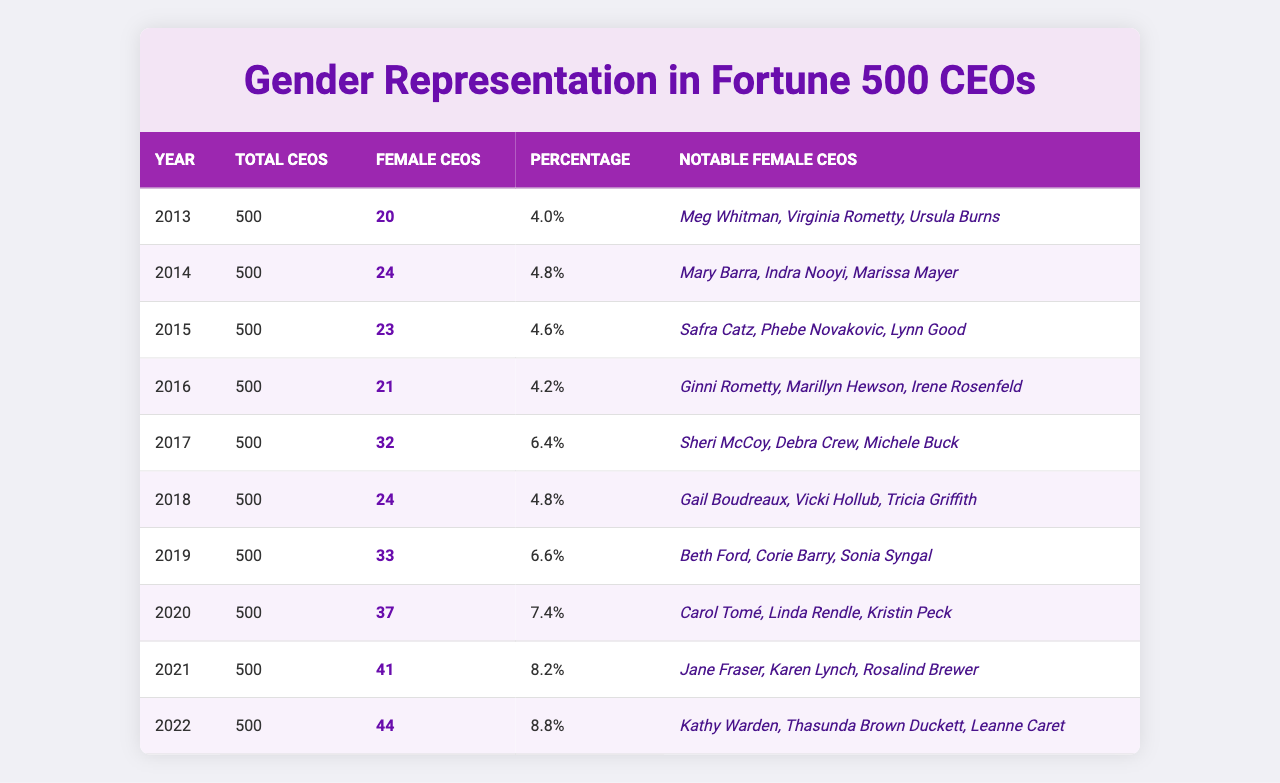What was the percentage of female CEOs in 2022? In 2022, there were 44 female CEOs out of 500 total CEOs. The percentage can be calculated as (44 / 500) * 100 = 8.8%.
Answer: 8.8% How many female CEOs were there in 2015? The table states that in 2015, there were 23 female CEOs.
Answer: 23 What was the total increase in the number of female CEOs from 2013 to 2022? In 2013, there were 20 female CEOs and in 2022 there were 44. Therefore, the increase is 44 - 20 = 24.
Answer: 24 Which year saw the highest number of female CEOs? By checking the data, the highest number of female CEOs occurred in 2022, with 44 female CEOs.
Answer: 2022 On average, how many female CEOs were there from 2013 to 2022? The total number of female CEOs from 2013 to 2022 is 20 + 24 + 23 + 21 + 32 + 24 + 33 + 37 + 41 + 44 =  299. There are 10 years, so the average is 299 / 10 = 29.9.
Answer: 29.9 Was there a year when the number of female CEOs decreased compared to the previous year? To find this, compare the number of female CEOs year-over-year. The data for 2015 (23) is less than that for 2014 (24), so yes, there was a decrease.
Answer: Yes What was the change in the number of female CEOs from 2019 to 2020? In 2019, there were 33 female CEOs and in 2020, there were 37. Thus, the change is 37 - 33 = 4.
Answer: 4 How many notable female CEOs were listed in 2016? According to the table, there are three notable female CEOs listed for 2016: Ginni Rometty, Marillyn Hewson, and Irene Rosenfeld.
Answer: 3 What was the average percentage of female CEOs from 2013 to 2022? Calculate the percentage for each year: 4%, 4.8%, 4.6%, 4.2%, 6.4%, 4.8%, 6.6%, 7.4%, 8.2%, 8.8%. The average percentage is (4 + 4.8 + 4.6 + 4.2 + 6.4 + 4.8 + 6.6 + 7.4 + 8.2 + 8.8) / 10 = 6.08.
Answer: 6.08 How many female CEOs were there in 2019 compared to 2021? In 2019, there were 33 female CEOs and in 2021 there were 41. Comparing these numbers shows that 41 is greater than 33, indicating an increase.
Answer: An increase Which year had the same number of total CEOs as the female CEOs in 2015? The total number of CEOs is the same every year, at 500. In 2015, there were 23 female CEOs, which indicates that no year has the same number of total CEOs (500) as female CEOs (23).
Answer: No year 